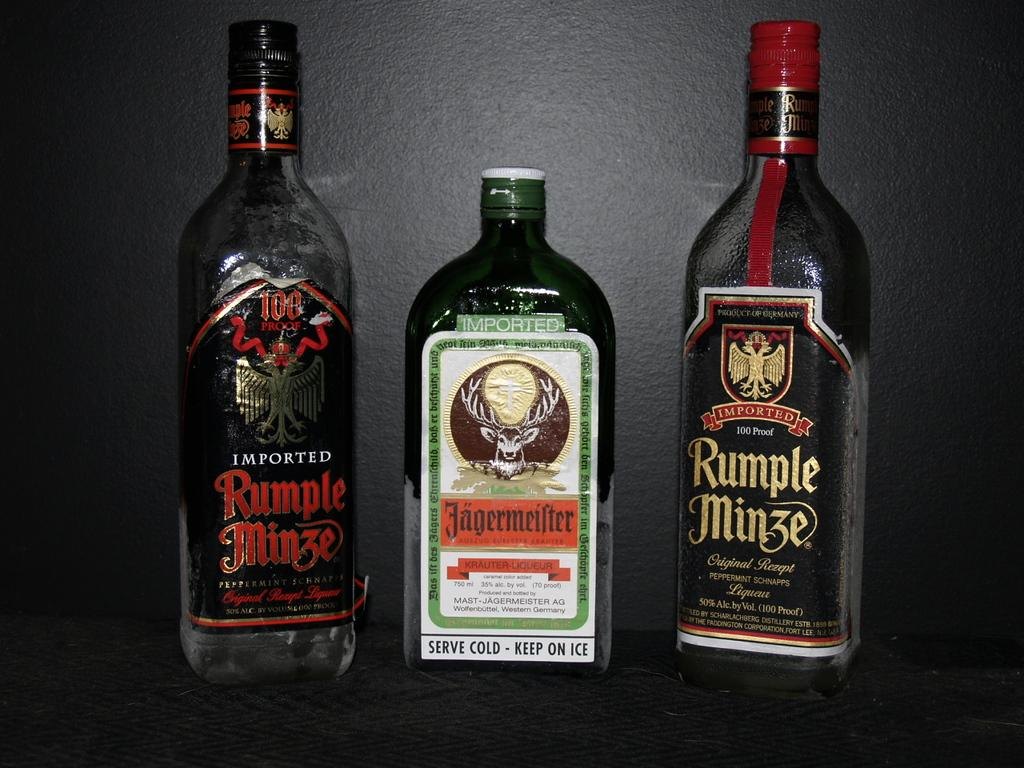<image>
Relay a brief, clear account of the picture shown. A bottle of Jagermeiter is between two bottles of Rumple Minze. 